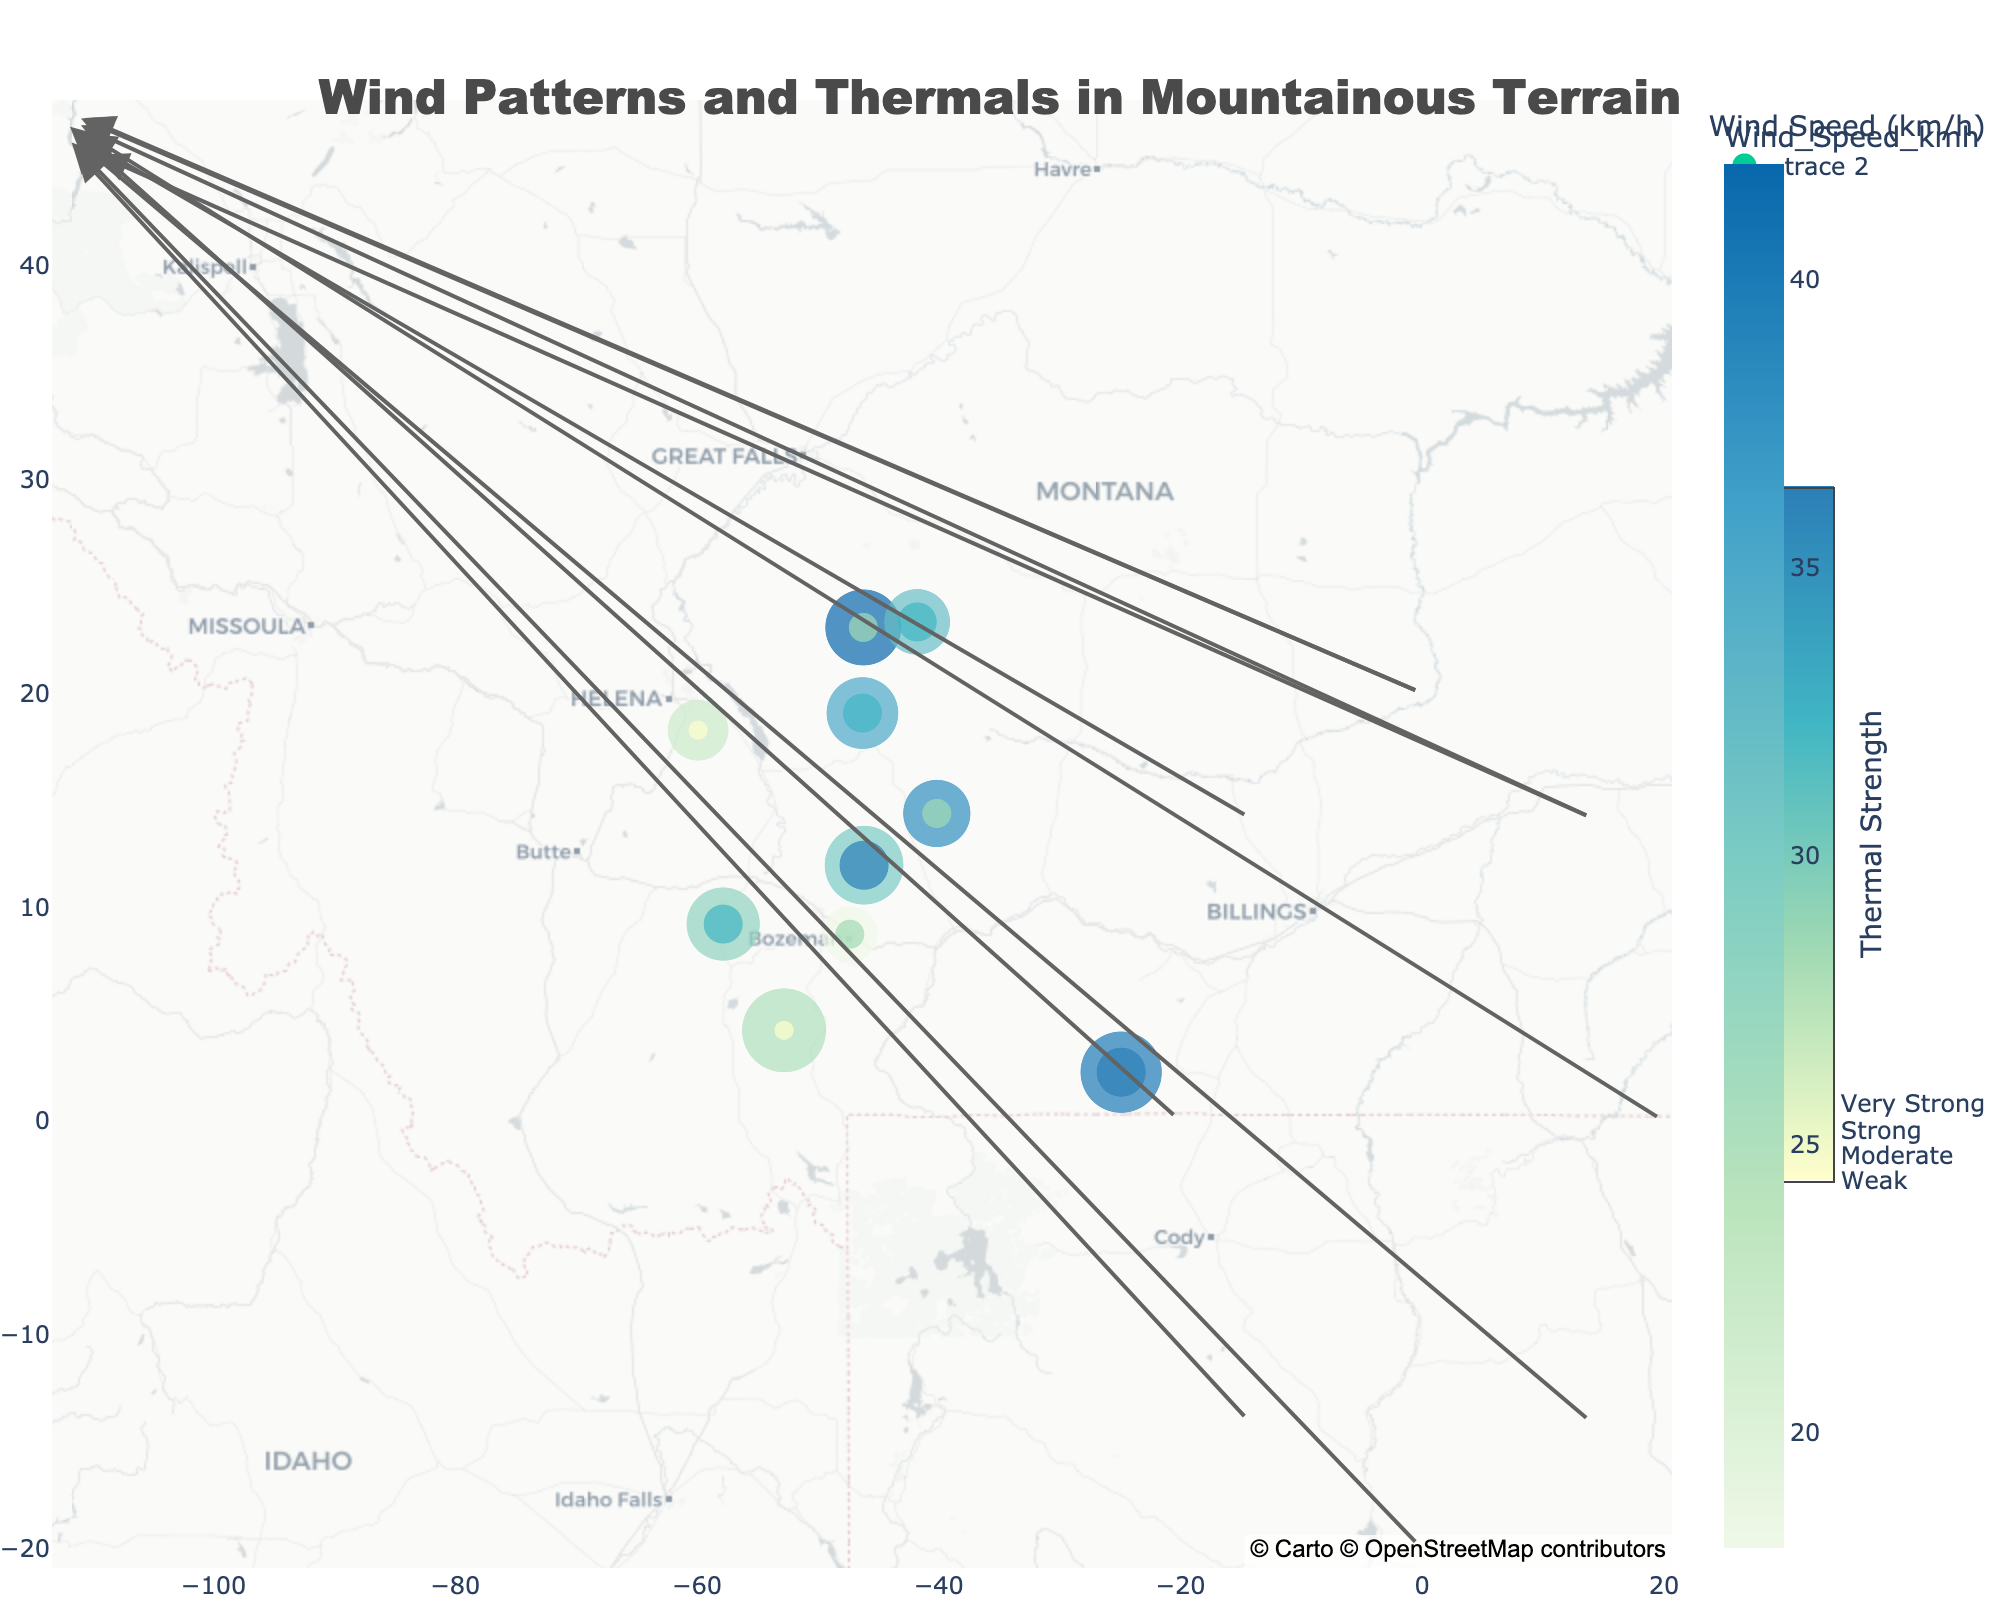What is the wind direction in the Little Belt Mountains? From the figure, find the point labeled "Little Belt Mountains" and check the corresponding wind direction annotation.
Answer: W Which location has the strongest thermal strength? Identify the point with the largest thermal marker on the map, which corresponds to "Very Strong" thermal strength.
Answer: Crazy Mountains, Beartooth Mountains How many locations have a wind speed greater than 35 km/h? Look for points in the figure with color representing wind speeds greater than 35 km/h. Count these points.
Answer: 5 What is the average elevation of the locations with 'Moderate' thermal strength? Identify locations marked as 'Moderate' thermal strength, note their elevations, sum them up, and divide by the number of these locations.
Answer: (2800 + 2200 + 1500) / 3 = 2166.67 meters Which direction is the wind blowing in Gallatin Range? Locate "Gallatin Range" on the map and check its corresponding wind direction annotation.
Answer: SE Compare the wind speeds between Crazy Mountains and Tobacco Root Mountains. Which one is higher? Locate both "Crazy Mountains" and "Tobacco Root Mountains" on the figure and compare their wind speed color representations.
Answer: Tobacco Root Mountains What is the predominant thermal strength in the Bridger Range? Find "Bridger Range" on the figure and observe the thermal marker color/size.
Answer: Strong Between the Beartooth Mountains and Big Snowy Mountains, which has a higher elevation? Locate both "Beartooth Mountains" and "Big Snowy Mountains" on the figure and note their elevation sizes.
Answer: Beartooth Mountains Which location has the weakest thermal strength? Identify the points with the smallest thermal markers that correspond to 'Weak' thermal strength.
Answer: Gallatin Range, Helena Valley 